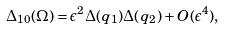Convert formula to latex. <formula><loc_0><loc_0><loc_500><loc_500>\Delta _ { 1 0 } ( \Omega ) = \epsilon ^ { 2 } \Delta ( q _ { 1 } ) \Delta ( q _ { 2 } ) + O ( \epsilon ^ { 4 } ) ,</formula> 